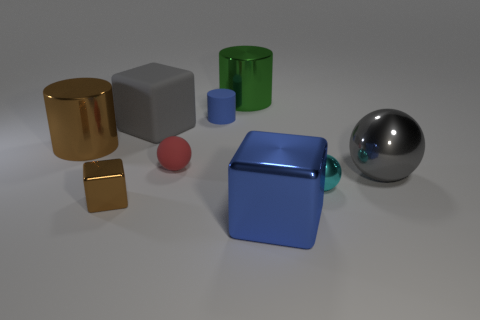The thing that is the same color as the rubber cylinder is what shape?
Your answer should be very brief. Cube. Is there anything else of the same color as the large rubber object?
Provide a short and direct response. Yes. Is there a tiny matte thing that has the same shape as the gray metal object?
Offer a very short reply. Yes. There is a small sphere right of the metallic cube to the right of the blue rubber cylinder; how many small blocks are in front of it?
Your answer should be very brief. 1. There is a matte block; does it have the same color as the big shiny sphere in front of the small red rubber ball?
Offer a terse response. Yes. What number of objects are big shiny things behind the tiny blue rubber object or large cylinders to the left of the large green thing?
Offer a very short reply. 2. Is the number of tiny cylinders that are behind the big brown shiny object greater than the number of big metallic balls to the left of the blue matte object?
Ensure brevity in your answer.  Yes. The gray thing on the right side of the metallic ball that is in front of the large gray object to the right of the cyan metallic ball is made of what material?
Give a very brief answer. Metal. There is a blue object in front of the blue cylinder; is its shape the same as the gray object left of the tiny red matte thing?
Your answer should be compact. Yes. Is there a blue block that has the same size as the gray rubber cube?
Your answer should be very brief. Yes. 